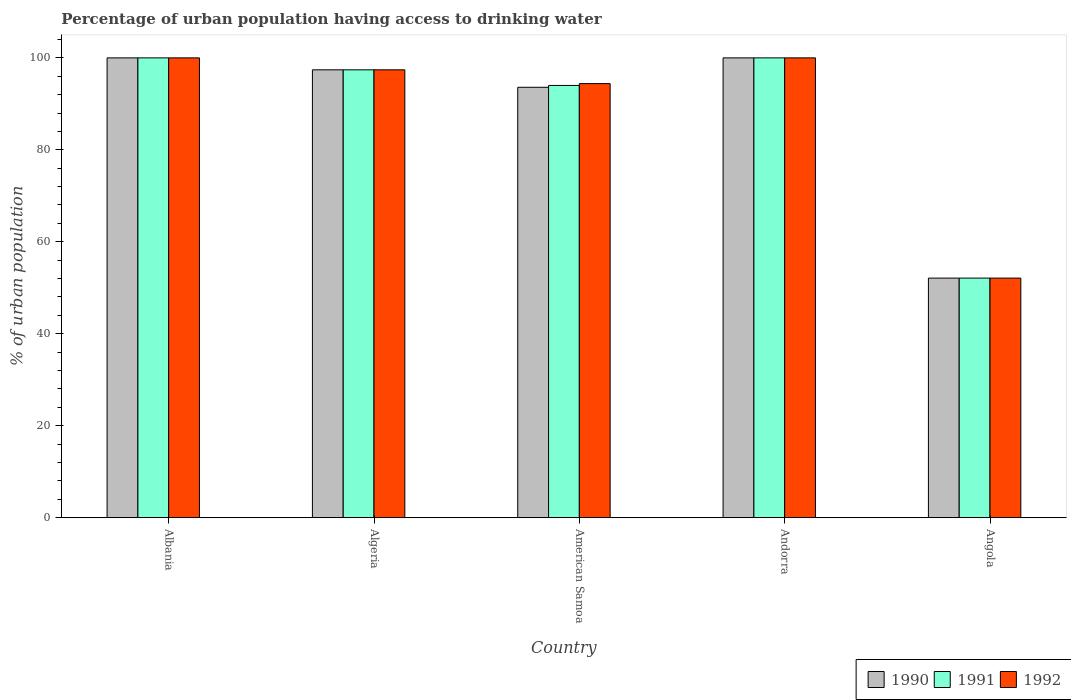How many groups of bars are there?
Your answer should be very brief. 5. Are the number of bars per tick equal to the number of legend labels?
Offer a very short reply. Yes. Are the number of bars on each tick of the X-axis equal?
Ensure brevity in your answer.  Yes. How many bars are there on the 5th tick from the right?
Offer a very short reply. 3. What is the label of the 3rd group of bars from the left?
Your answer should be very brief. American Samoa. In how many cases, is the number of bars for a given country not equal to the number of legend labels?
Provide a short and direct response. 0. What is the percentage of urban population having access to drinking water in 1992 in Angola?
Give a very brief answer. 52.1. Across all countries, what is the minimum percentage of urban population having access to drinking water in 1991?
Keep it short and to the point. 52.1. In which country was the percentage of urban population having access to drinking water in 1990 maximum?
Provide a short and direct response. Albania. In which country was the percentage of urban population having access to drinking water in 1991 minimum?
Offer a very short reply. Angola. What is the total percentage of urban population having access to drinking water in 1991 in the graph?
Provide a succinct answer. 443.5. What is the difference between the percentage of urban population having access to drinking water in 1992 in American Samoa and that in Angola?
Your answer should be compact. 42.3. What is the average percentage of urban population having access to drinking water in 1992 per country?
Offer a very short reply. 88.78. What is the difference between the percentage of urban population having access to drinking water of/in 1990 and percentage of urban population having access to drinking water of/in 1991 in Andorra?
Provide a short and direct response. 0. What is the ratio of the percentage of urban population having access to drinking water in 1990 in Algeria to that in Andorra?
Offer a very short reply. 0.97. Is the percentage of urban population having access to drinking water in 1992 in American Samoa less than that in Angola?
Offer a terse response. No. Is the difference between the percentage of urban population having access to drinking water in 1990 in Andorra and Angola greater than the difference between the percentage of urban population having access to drinking water in 1991 in Andorra and Angola?
Offer a terse response. No. What is the difference between the highest and the second highest percentage of urban population having access to drinking water in 1991?
Your response must be concise. -2.6. What is the difference between the highest and the lowest percentage of urban population having access to drinking water in 1991?
Provide a short and direct response. 47.9. In how many countries, is the percentage of urban population having access to drinking water in 1992 greater than the average percentage of urban population having access to drinking water in 1992 taken over all countries?
Offer a terse response. 4. Is the sum of the percentage of urban population having access to drinking water in 1991 in Albania and American Samoa greater than the maximum percentage of urban population having access to drinking water in 1990 across all countries?
Your answer should be very brief. Yes. Is it the case that in every country, the sum of the percentage of urban population having access to drinking water in 1991 and percentage of urban population having access to drinking water in 1992 is greater than the percentage of urban population having access to drinking water in 1990?
Keep it short and to the point. Yes. How many bars are there?
Your answer should be very brief. 15. How many countries are there in the graph?
Your answer should be very brief. 5. What is the difference between two consecutive major ticks on the Y-axis?
Your answer should be compact. 20. How are the legend labels stacked?
Offer a very short reply. Horizontal. What is the title of the graph?
Make the answer very short. Percentage of urban population having access to drinking water. What is the label or title of the X-axis?
Make the answer very short. Country. What is the label or title of the Y-axis?
Provide a short and direct response. % of urban population. What is the % of urban population in 1990 in Albania?
Your answer should be compact. 100. What is the % of urban population in 1991 in Albania?
Ensure brevity in your answer.  100. What is the % of urban population of 1990 in Algeria?
Give a very brief answer. 97.4. What is the % of urban population in 1991 in Algeria?
Offer a very short reply. 97.4. What is the % of urban population in 1992 in Algeria?
Ensure brevity in your answer.  97.4. What is the % of urban population of 1990 in American Samoa?
Keep it short and to the point. 93.6. What is the % of urban population of 1991 in American Samoa?
Provide a succinct answer. 94. What is the % of urban population of 1992 in American Samoa?
Ensure brevity in your answer.  94.4. What is the % of urban population of 1992 in Andorra?
Your answer should be compact. 100. What is the % of urban population of 1990 in Angola?
Provide a succinct answer. 52.1. What is the % of urban population of 1991 in Angola?
Give a very brief answer. 52.1. What is the % of urban population in 1992 in Angola?
Provide a short and direct response. 52.1. Across all countries, what is the maximum % of urban population of 1991?
Provide a succinct answer. 100. Across all countries, what is the minimum % of urban population in 1990?
Offer a terse response. 52.1. Across all countries, what is the minimum % of urban population of 1991?
Give a very brief answer. 52.1. Across all countries, what is the minimum % of urban population of 1992?
Your answer should be compact. 52.1. What is the total % of urban population in 1990 in the graph?
Provide a short and direct response. 443.1. What is the total % of urban population in 1991 in the graph?
Your answer should be compact. 443.5. What is the total % of urban population of 1992 in the graph?
Ensure brevity in your answer.  443.9. What is the difference between the % of urban population of 1990 in Albania and that in Algeria?
Provide a short and direct response. 2.6. What is the difference between the % of urban population in 1991 in Albania and that in Algeria?
Make the answer very short. 2.6. What is the difference between the % of urban population in 1992 in Albania and that in Algeria?
Offer a terse response. 2.6. What is the difference between the % of urban population in 1991 in Albania and that in American Samoa?
Offer a very short reply. 6. What is the difference between the % of urban population in 1992 in Albania and that in American Samoa?
Provide a short and direct response. 5.6. What is the difference between the % of urban population in 1990 in Albania and that in Andorra?
Provide a succinct answer. 0. What is the difference between the % of urban population of 1992 in Albania and that in Andorra?
Ensure brevity in your answer.  0. What is the difference between the % of urban population in 1990 in Albania and that in Angola?
Offer a very short reply. 47.9. What is the difference between the % of urban population in 1991 in Albania and that in Angola?
Provide a short and direct response. 47.9. What is the difference between the % of urban population of 1992 in Albania and that in Angola?
Your answer should be very brief. 47.9. What is the difference between the % of urban population of 1990 in Algeria and that in American Samoa?
Make the answer very short. 3.8. What is the difference between the % of urban population in 1992 in Algeria and that in American Samoa?
Your answer should be compact. 3. What is the difference between the % of urban population in 1992 in Algeria and that in Andorra?
Your answer should be very brief. -2.6. What is the difference between the % of urban population of 1990 in Algeria and that in Angola?
Offer a very short reply. 45.3. What is the difference between the % of urban population in 1991 in Algeria and that in Angola?
Offer a very short reply. 45.3. What is the difference between the % of urban population of 1992 in Algeria and that in Angola?
Make the answer very short. 45.3. What is the difference between the % of urban population in 1990 in American Samoa and that in Andorra?
Provide a short and direct response. -6.4. What is the difference between the % of urban population in 1991 in American Samoa and that in Andorra?
Offer a terse response. -6. What is the difference between the % of urban population in 1990 in American Samoa and that in Angola?
Offer a terse response. 41.5. What is the difference between the % of urban population of 1991 in American Samoa and that in Angola?
Provide a succinct answer. 41.9. What is the difference between the % of urban population of 1992 in American Samoa and that in Angola?
Keep it short and to the point. 42.3. What is the difference between the % of urban population of 1990 in Andorra and that in Angola?
Offer a very short reply. 47.9. What is the difference between the % of urban population of 1991 in Andorra and that in Angola?
Ensure brevity in your answer.  47.9. What is the difference between the % of urban population in 1992 in Andorra and that in Angola?
Make the answer very short. 47.9. What is the difference between the % of urban population of 1990 in Albania and the % of urban population of 1991 in Algeria?
Provide a succinct answer. 2.6. What is the difference between the % of urban population of 1991 in Albania and the % of urban population of 1992 in Algeria?
Provide a short and direct response. 2.6. What is the difference between the % of urban population of 1990 in Albania and the % of urban population of 1991 in American Samoa?
Make the answer very short. 6. What is the difference between the % of urban population in 1990 in Albania and the % of urban population in 1992 in American Samoa?
Ensure brevity in your answer.  5.6. What is the difference between the % of urban population of 1990 in Albania and the % of urban population of 1991 in Angola?
Ensure brevity in your answer.  47.9. What is the difference between the % of urban population of 1990 in Albania and the % of urban population of 1992 in Angola?
Provide a short and direct response. 47.9. What is the difference between the % of urban population of 1991 in Albania and the % of urban population of 1992 in Angola?
Ensure brevity in your answer.  47.9. What is the difference between the % of urban population in 1990 in Algeria and the % of urban population in 1991 in American Samoa?
Make the answer very short. 3.4. What is the difference between the % of urban population of 1990 in Algeria and the % of urban population of 1992 in American Samoa?
Offer a terse response. 3. What is the difference between the % of urban population of 1991 in Algeria and the % of urban population of 1992 in American Samoa?
Your answer should be compact. 3. What is the difference between the % of urban population of 1991 in Algeria and the % of urban population of 1992 in Andorra?
Ensure brevity in your answer.  -2.6. What is the difference between the % of urban population in 1990 in Algeria and the % of urban population in 1991 in Angola?
Offer a very short reply. 45.3. What is the difference between the % of urban population in 1990 in Algeria and the % of urban population in 1992 in Angola?
Make the answer very short. 45.3. What is the difference between the % of urban population in 1991 in Algeria and the % of urban population in 1992 in Angola?
Keep it short and to the point. 45.3. What is the difference between the % of urban population of 1990 in American Samoa and the % of urban population of 1991 in Angola?
Give a very brief answer. 41.5. What is the difference between the % of urban population of 1990 in American Samoa and the % of urban population of 1992 in Angola?
Keep it short and to the point. 41.5. What is the difference between the % of urban population of 1991 in American Samoa and the % of urban population of 1992 in Angola?
Provide a short and direct response. 41.9. What is the difference between the % of urban population of 1990 in Andorra and the % of urban population of 1991 in Angola?
Ensure brevity in your answer.  47.9. What is the difference between the % of urban population of 1990 in Andorra and the % of urban population of 1992 in Angola?
Make the answer very short. 47.9. What is the difference between the % of urban population of 1991 in Andorra and the % of urban population of 1992 in Angola?
Give a very brief answer. 47.9. What is the average % of urban population in 1990 per country?
Keep it short and to the point. 88.62. What is the average % of urban population of 1991 per country?
Offer a terse response. 88.7. What is the average % of urban population of 1992 per country?
Offer a terse response. 88.78. What is the difference between the % of urban population in 1990 and % of urban population in 1992 in Albania?
Provide a short and direct response. 0. What is the difference between the % of urban population in 1990 and % of urban population in 1991 in Algeria?
Provide a succinct answer. 0. What is the difference between the % of urban population in 1991 and % of urban population in 1992 in Algeria?
Ensure brevity in your answer.  0. What is the difference between the % of urban population of 1990 and % of urban population of 1991 in American Samoa?
Your response must be concise. -0.4. What is the difference between the % of urban population in 1990 and % of urban population in 1992 in American Samoa?
Provide a short and direct response. -0.8. What is the ratio of the % of urban population in 1990 in Albania to that in Algeria?
Provide a short and direct response. 1.03. What is the ratio of the % of urban population of 1991 in Albania to that in Algeria?
Make the answer very short. 1.03. What is the ratio of the % of urban population of 1992 in Albania to that in Algeria?
Your response must be concise. 1.03. What is the ratio of the % of urban population of 1990 in Albania to that in American Samoa?
Your answer should be very brief. 1.07. What is the ratio of the % of urban population in 1991 in Albania to that in American Samoa?
Your response must be concise. 1.06. What is the ratio of the % of urban population in 1992 in Albania to that in American Samoa?
Keep it short and to the point. 1.06. What is the ratio of the % of urban population in 1990 in Albania to that in Angola?
Provide a short and direct response. 1.92. What is the ratio of the % of urban population of 1991 in Albania to that in Angola?
Give a very brief answer. 1.92. What is the ratio of the % of urban population of 1992 in Albania to that in Angola?
Ensure brevity in your answer.  1.92. What is the ratio of the % of urban population in 1990 in Algeria to that in American Samoa?
Offer a terse response. 1.04. What is the ratio of the % of urban population in 1991 in Algeria to that in American Samoa?
Offer a terse response. 1.04. What is the ratio of the % of urban population in 1992 in Algeria to that in American Samoa?
Give a very brief answer. 1.03. What is the ratio of the % of urban population of 1990 in Algeria to that in Andorra?
Make the answer very short. 0.97. What is the ratio of the % of urban population in 1991 in Algeria to that in Andorra?
Give a very brief answer. 0.97. What is the ratio of the % of urban population of 1990 in Algeria to that in Angola?
Offer a very short reply. 1.87. What is the ratio of the % of urban population in 1991 in Algeria to that in Angola?
Provide a succinct answer. 1.87. What is the ratio of the % of urban population of 1992 in Algeria to that in Angola?
Provide a succinct answer. 1.87. What is the ratio of the % of urban population of 1990 in American Samoa to that in Andorra?
Give a very brief answer. 0.94. What is the ratio of the % of urban population of 1991 in American Samoa to that in Andorra?
Ensure brevity in your answer.  0.94. What is the ratio of the % of urban population of 1992 in American Samoa to that in Andorra?
Offer a terse response. 0.94. What is the ratio of the % of urban population in 1990 in American Samoa to that in Angola?
Keep it short and to the point. 1.8. What is the ratio of the % of urban population in 1991 in American Samoa to that in Angola?
Your answer should be compact. 1.8. What is the ratio of the % of urban population of 1992 in American Samoa to that in Angola?
Provide a short and direct response. 1.81. What is the ratio of the % of urban population in 1990 in Andorra to that in Angola?
Provide a short and direct response. 1.92. What is the ratio of the % of urban population in 1991 in Andorra to that in Angola?
Offer a very short reply. 1.92. What is the ratio of the % of urban population in 1992 in Andorra to that in Angola?
Your answer should be compact. 1.92. What is the difference between the highest and the second highest % of urban population of 1992?
Keep it short and to the point. 0. What is the difference between the highest and the lowest % of urban population of 1990?
Your answer should be very brief. 47.9. What is the difference between the highest and the lowest % of urban population of 1991?
Ensure brevity in your answer.  47.9. What is the difference between the highest and the lowest % of urban population in 1992?
Ensure brevity in your answer.  47.9. 